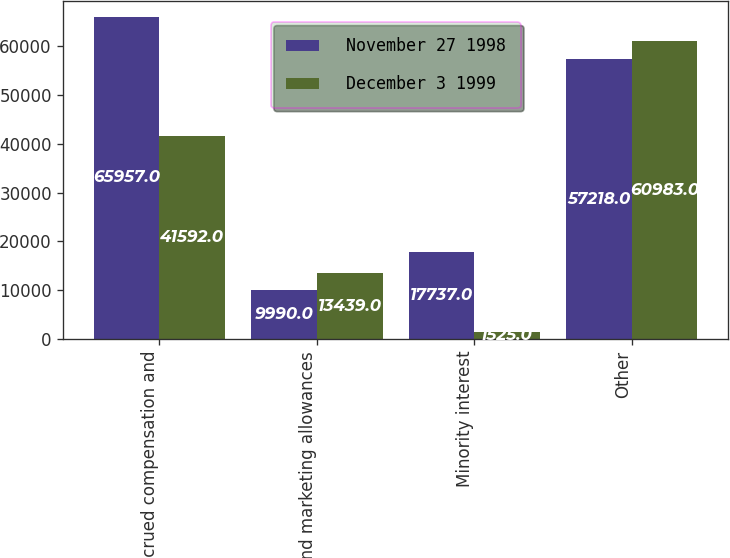<chart> <loc_0><loc_0><loc_500><loc_500><stacked_bar_chart><ecel><fcel>Accrued compensation and<fcel>Sales and marketing allowances<fcel>Minority interest<fcel>Other<nl><fcel>November 27 1998<fcel>65957<fcel>9990<fcel>17737<fcel>57218<nl><fcel>December 3 1999<fcel>41592<fcel>13439<fcel>1525<fcel>60983<nl></chart> 